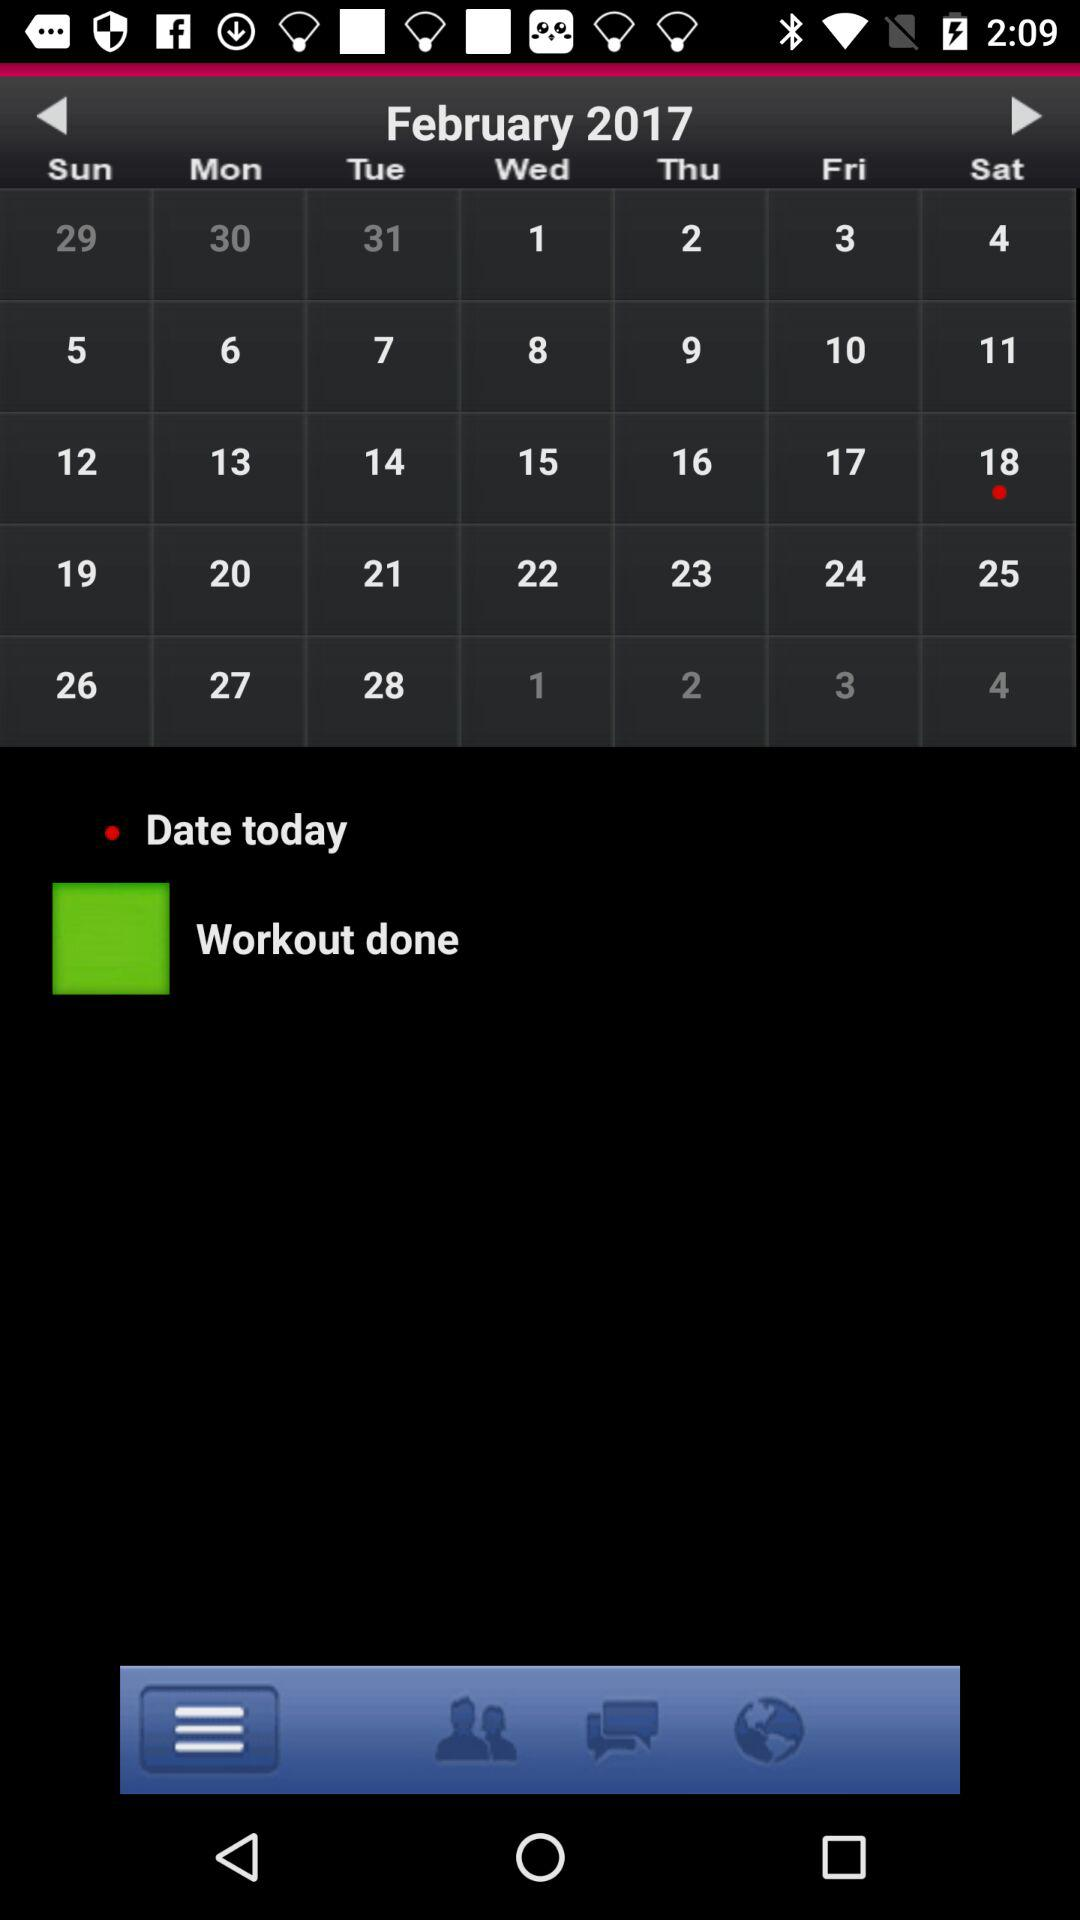What is the date today? The date today is Saturday, February 18, 2017. 